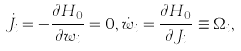<formula> <loc_0><loc_0><loc_500><loc_500>\dot { J } _ { i } = - \frac { \partial H _ { 0 } } { \partial w _ { i } } = 0 , \dot { w } _ { i } = \frac { \partial H _ { 0 } } { \partial J _ { i } } \equiv \Omega _ { i } ,</formula> 